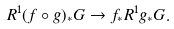Convert formula to latex. <formula><loc_0><loc_0><loc_500><loc_500>R ^ { 1 } ( f \circ g ) _ { * } G \to f _ { * } R ^ { 1 } g _ { * } G .</formula> 